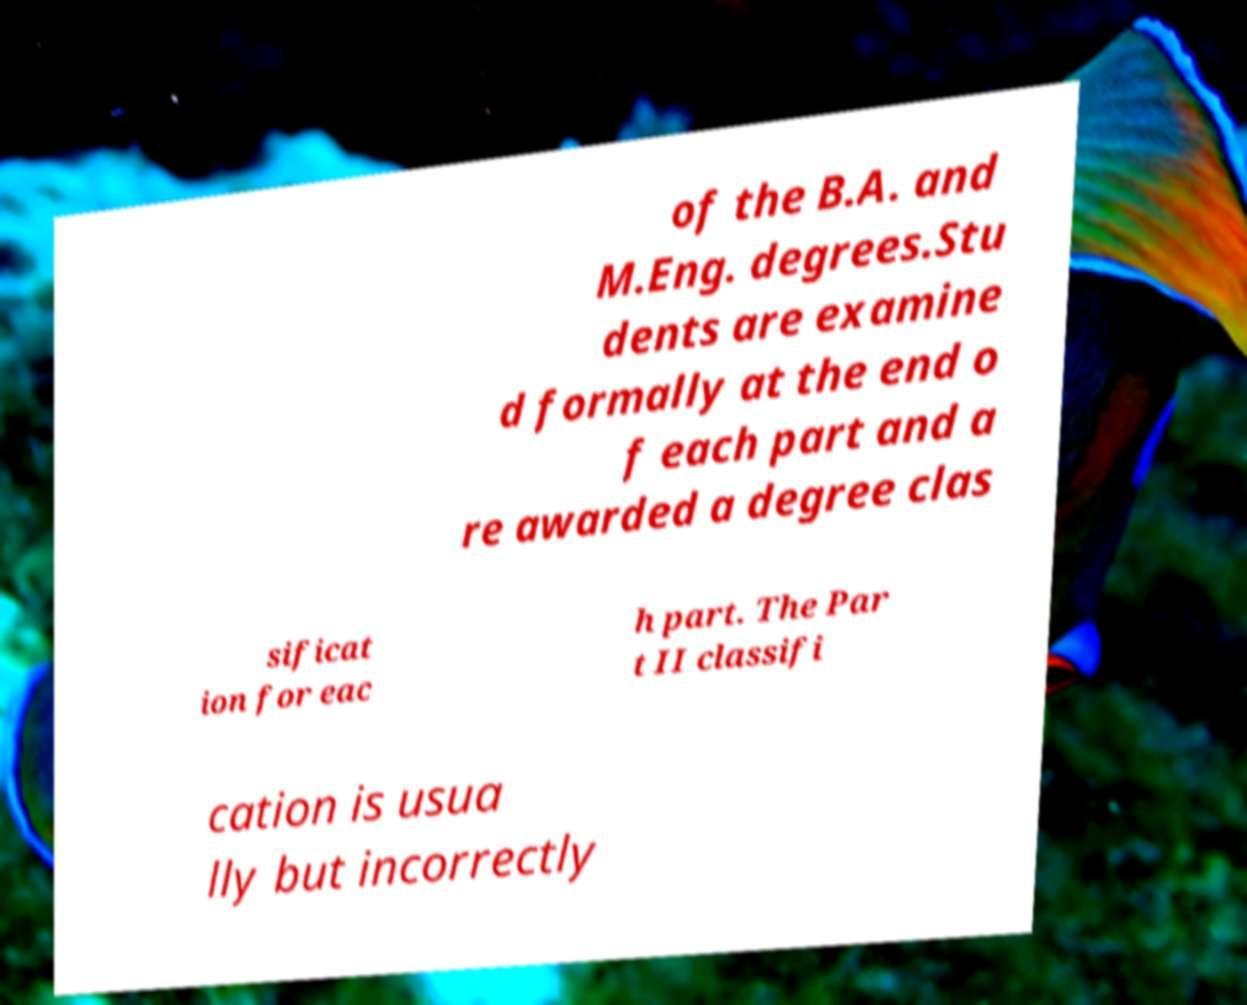Please read and relay the text visible in this image. What does it say? of the B.A. and M.Eng. degrees.Stu dents are examine d formally at the end o f each part and a re awarded a degree clas sificat ion for eac h part. The Par t II classifi cation is usua lly but incorrectly 